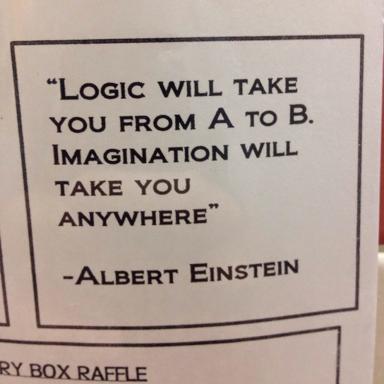Who is the author of the quote? The author of the inspiring quote in the image is none other than Albert Einstein, a prominent physicist known for his theories of relativity. He often emphasized the power of imagination in scientific inquiry and problem-solving. 